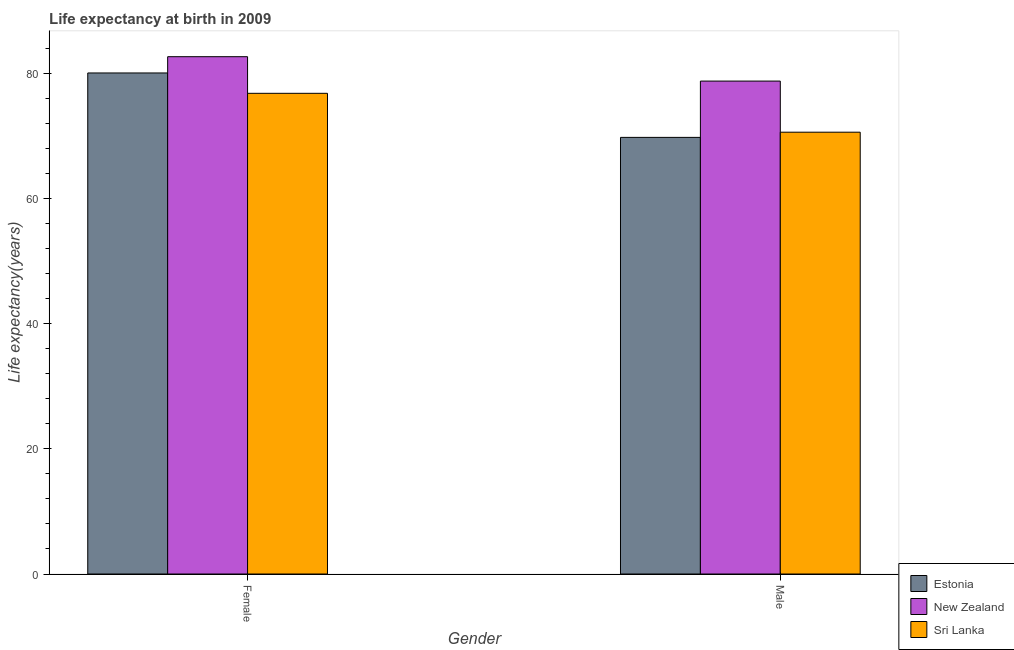Are the number of bars per tick equal to the number of legend labels?
Your answer should be compact. Yes. Are the number of bars on each tick of the X-axis equal?
Provide a short and direct response. Yes. How many bars are there on the 1st tick from the right?
Give a very brief answer. 3. What is the label of the 2nd group of bars from the left?
Your answer should be compact. Male. What is the life expectancy(female) in New Zealand?
Give a very brief answer. 82.7. Across all countries, what is the maximum life expectancy(female)?
Make the answer very short. 82.7. Across all countries, what is the minimum life expectancy(female)?
Your response must be concise. 76.84. In which country was the life expectancy(male) maximum?
Offer a very short reply. New Zealand. In which country was the life expectancy(male) minimum?
Keep it short and to the point. Estonia. What is the total life expectancy(female) in the graph?
Offer a terse response. 239.65. What is the difference between the life expectancy(male) in Sri Lanka and that in New Zealand?
Your answer should be compact. -8.17. What is the difference between the life expectancy(female) in New Zealand and the life expectancy(male) in Sri Lanka?
Keep it short and to the point. 12.07. What is the average life expectancy(male) per country?
Provide a succinct answer. 73.08. What is the difference between the life expectancy(female) and life expectancy(male) in Estonia?
Give a very brief answer. 10.3. What is the ratio of the life expectancy(female) in Estonia to that in Sri Lanka?
Provide a short and direct response. 1.04. Is the life expectancy(female) in New Zealand less than that in Estonia?
Make the answer very short. No. In how many countries, is the life expectancy(male) greater than the average life expectancy(male) taken over all countries?
Your answer should be very brief. 1. What does the 3rd bar from the left in Female represents?
Your response must be concise. Sri Lanka. What does the 3rd bar from the right in Male represents?
Provide a succinct answer. Estonia. How many countries are there in the graph?
Your answer should be very brief. 3. Are the values on the major ticks of Y-axis written in scientific E-notation?
Provide a short and direct response. No. Does the graph contain any zero values?
Your answer should be very brief. No. Does the graph contain grids?
Offer a terse response. No. Where does the legend appear in the graph?
Your answer should be compact. Bottom right. How many legend labels are there?
Provide a succinct answer. 3. How are the legend labels stacked?
Offer a very short reply. Vertical. What is the title of the graph?
Offer a very short reply. Life expectancy at birth in 2009. What is the label or title of the X-axis?
Offer a very short reply. Gender. What is the label or title of the Y-axis?
Your answer should be compact. Life expectancy(years). What is the Life expectancy(years) of Estonia in Female?
Make the answer very short. 80.1. What is the Life expectancy(years) of New Zealand in Female?
Ensure brevity in your answer.  82.7. What is the Life expectancy(years) of Sri Lanka in Female?
Ensure brevity in your answer.  76.84. What is the Life expectancy(years) of Estonia in Male?
Offer a very short reply. 69.8. What is the Life expectancy(years) in New Zealand in Male?
Ensure brevity in your answer.  78.8. What is the Life expectancy(years) of Sri Lanka in Male?
Provide a succinct answer. 70.63. Across all Gender, what is the maximum Life expectancy(years) of Estonia?
Your answer should be very brief. 80.1. Across all Gender, what is the maximum Life expectancy(years) of New Zealand?
Offer a terse response. 82.7. Across all Gender, what is the maximum Life expectancy(years) of Sri Lanka?
Offer a very short reply. 76.84. Across all Gender, what is the minimum Life expectancy(years) of Estonia?
Offer a terse response. 69.8. Across all Gender, what is the minimum Life expectancy(years) of New Zealand?
Provide a short and direct response. 78.8. Across all Gender, what is the minimum Life expectancy(years) of Sri Lanka?
Make the answer very short. 70.63. What is the total Life expectancy(years) in Estonia in the graph?
Keep it short and to the point. 149.9. What is the total Life expectancy(years) of New Zealand in the graph?
Provide a succinct answer. 161.5. What is the total Life expectancy(years) of Sri Lanka in the graph?
Your answer should be compact. 147.47. What is the difference between the Life expectancy(years) of Estonia in Female and that in Male?
Provide a short and direct response. 10.3. What is the difference between the Life expectancy(years) in Sri Lanka in Female and that in Male?
Make the answer very short. 6.22. What is the difference between the Life expectancy(years) of Estonia in Female and the Life expectancy(years) of Sri Lanka in Male?
Offer a very short reply. 9.47. What is the difference between the Life expectancy(years) in New Zealand in Female and the Life expectancy(years) in Sri Lanka in Male?
Provide a succinct answer. 12.07. What is the average Life expectancy(years) in Estonia per Gender?
Give a very brief answer. 74.95. What is the average Life expectancy(years) in New Zealand per Gender?
Offer a very short reply. 80.75. What is the average Life expectancy(years) of Sri Lanka per Gender?
Provide a succinct answer. 73.74. What is the difference between the Life expectancy(years) in Estonia and Life expectancy(years) in Sri Lanka in Female?
Your answer should be very brief. 3.25. What is the difference between the Life expectancy(years) in New Zealand and Life expectancy(years) in Sri Lanka in Female?
Provide a succinct answer. 5.86. What is the difference between the Life expectancy(years) of Estonia and Life expectancy(years) of Sri Lanka in Male?
Give a very brief answer. -0.83. What is the difference between the Life expectancy(years) in New Zealand and Life expectancy(years) in Sri Lanka in Male?
Your answer should be very brief. 8.17. What is the ratio of the Life expectancy(years) in Estonia in Female to that in Male?
Give a very brief answer. 1.15. What is the ratio of the Life expectancy(years) of New Zealand in Female to that in Male?
Provide a short and direct response. 1.05. What is the ratio of the Life expectancy(years) of Sri Lanka in Female to that in Male?
Ensure brevity in your answer.  1.09. What is the difference between the highest and the second highest Life expectancy(years) in Sri Lanka?
Your answer should be compact. 6.22. What is the difference between the highest and the lowest Life expectancy(years) in New Zealand?
Offer a very short reply. 3.9. What is the difference between the highest and the lowest Life expectancy(years) of Sri Lanka?
Keep it short and to the point. 6.22. 